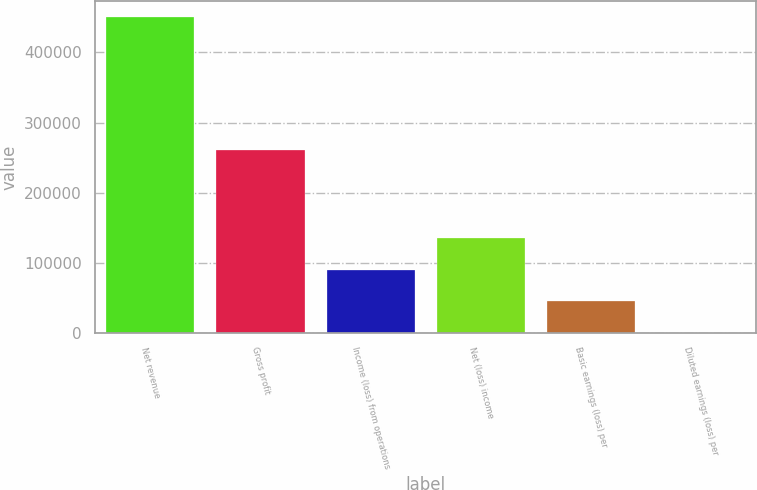Convert chart. <chart><loc_0><loc_0><loc_500><loc_500><bar_chart><fcel>Net revenue<fcel>Gross profit<fcel>Income (loss) from operations<fcel>Net (loss) income<fcel>Basic earnings (loss) per<fcel>Diluted earnings (loss) per<nl><fcel>450274<fcel>261063<fcel>90055.4<fcel>135083<fcel>45028.1<fcel>0.77<nl></chart> 